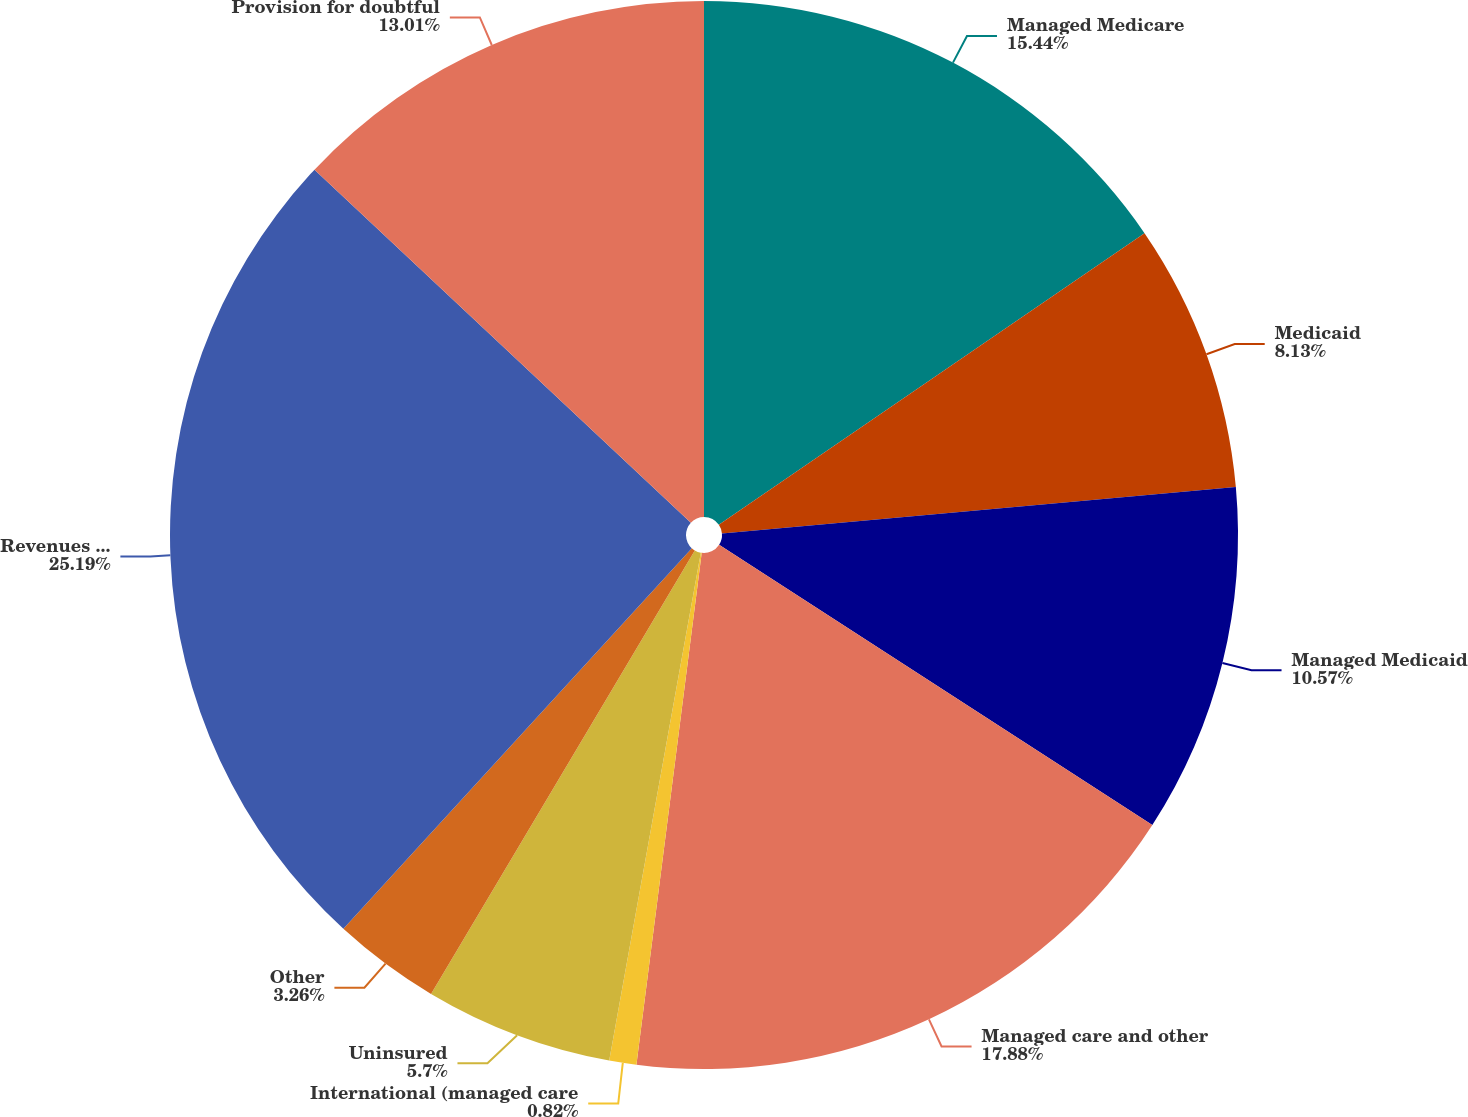<chart> <loc_0><loc_0><loc_500><loc_500><pie_chart><fcel>Managed Medicare<fcel>Medicaid<fcel>Managed Medicaid<fcel>Managed care and other<fcel>International (managed care<fcel>Uninsured<fcel>Other<fcel>Revenues before provision for<fcel>Provision for doubtful<nl><fcel>15.44%<fcel>8.13%<fcel>10.57%<fcel>17.88%<fcel>0.82%<fcel>5.7%<fcel>3.26%<fcel>25.19%<fcel>13.01%<nl></chart> 